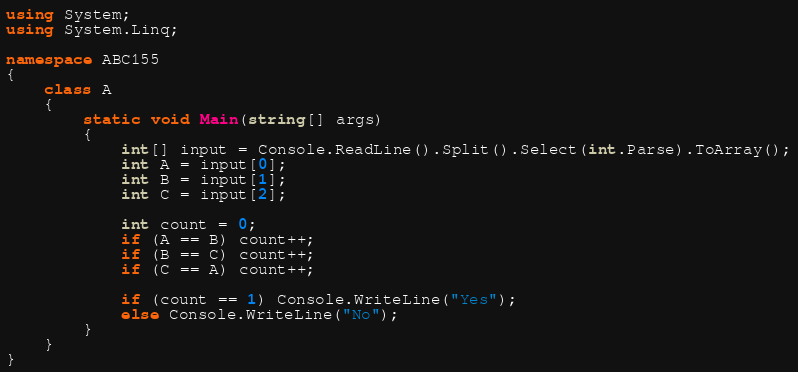<code> <loc_0><loc_0><loc_500><loc_500><_C#_>using System;
using System.Linq;

namespace ABC155
{
    class A
    {
        static void Main(string[] args)
        {
            int[] input = Console.ReadLine().Split().Select(int.Parse).ToArray();
            int A = input[0];
            int B = input[1];
            int C = input[2];

            int count = 0;
            if (A == B) count++;
            if (B == C) count++;
            if (C == A) count++;

            if (count == 1) Console.WriteLine("Yes");
            else Console.WriteLine("No");
        }
    }
}
</code> 